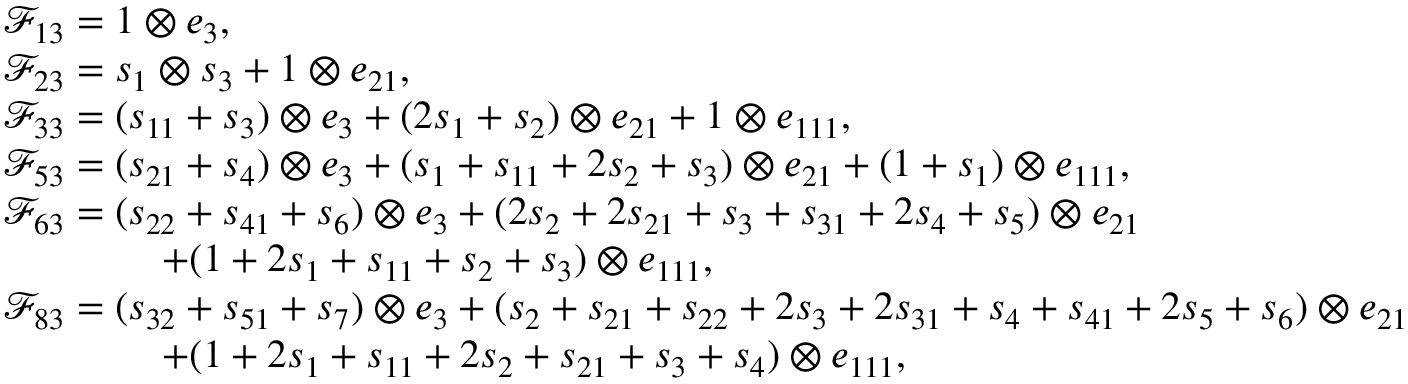Convert formula to latex. <formula><loc_0><loc_0><loc_500><loc_500>\begin{array} { r l } & { \mathcal { F } _ { 1 3 } = 1 \otimes e _ { 3 } , } \\ & { \mathcal { F } _ { 2 3 } = s _ { 1 } \otimes s _ { 3 } + 1 \otimes e _ { 2 1 } , } \\ & { \mathcal { F } _ { 3 3 } = ( s _ { 1 1 } + s _ { 3 } ) \otimes e _ { 3 } + ( 2 s _ { 1 } + s _ { 2 } ) \otimes e _ { 2 1 } + 1 \otimes e _ { 1 1 1 } , } \\ & { \mathcal { F } _ { 5 3 } = ( s _ { 2 1 } + s _ { 4 } ) \otimes e _ { 3 } + ( s _ { 1 } + s _ { 1 1 } + 2 s _ { 2 } + s _ { 3 } ) \otimes e _ { 2 1 } + ( 1 + s _ { 1 } ) \otimes e _ { 1 1 1 } , } \\ & { \mathcal { F } _ { 6 3 } = ( s _ { 2 2 } + s _ { 4 1 } + s _ { 6 } ) \otimes e _ { 3 } + ( 2 s _ { 2 } + 2 s _ { 2 1 } + s _ { 3 } + s _ { 3 1 } + 2 s _ { 4 } + s _ { 5 } ) \otimes e _ { 2 1 } } \\ & { \quad + ( 1 + 2 s _ { 1 } + s _ { 1 1 } + s _ { 2 } + s _ { 3 } ) \otimes e _ { 1 1 1 } , } \\ & { \mathcal { F } _ { 8 3 } = ( s _ { 3 2 } + s _ { 5 1 } + s _ { 7 } ) \otimes e _ { 3 } + ( s _ { 2 } + s _ { 2 1 } + s _ { 2 2 } + 2 s _ { 3 } + 2 s _ { 3 1 } + s _ { 4 } + s _ { 4 1 } + 2 s _ { 5 } + s _ { 6 } ) \otimes e _ { 2 1 } } \\ & { \quad + ( 1 + 2 s _ { 1 } + s _ { 1 1 } + 2 s _ { 2 } + s _ { 2 1 } + s _ { 3 } + s _ { 4 } ) \otimes e _ { 1 1 1 } , } \end{array}</formula> 